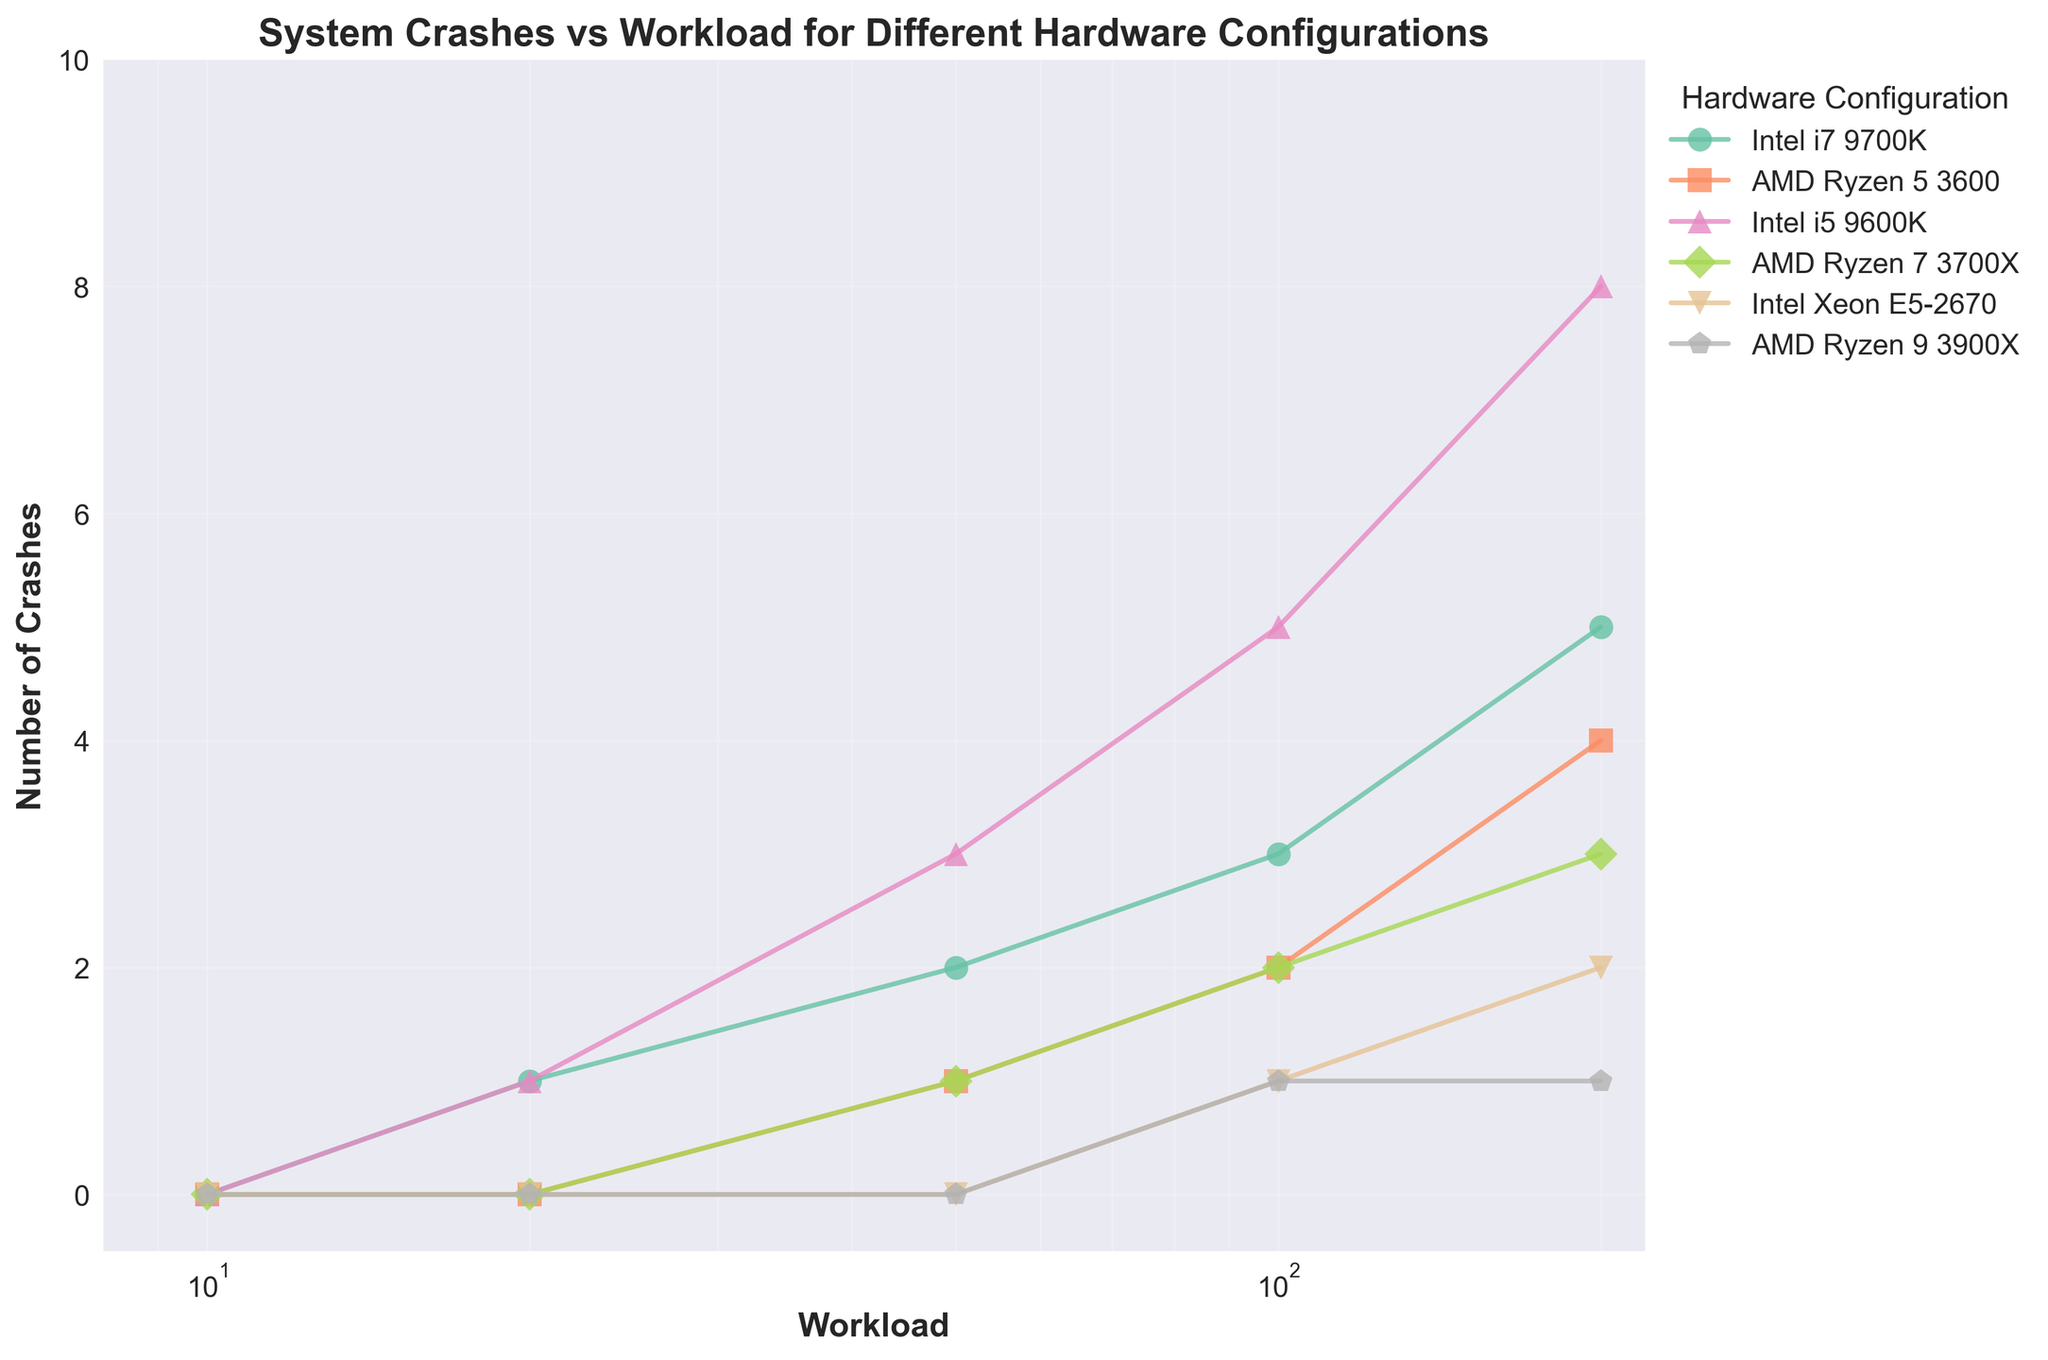What's the title of the plot? The title is located at the top-center of the plot. It serves as a summary of what the graph represents.
Answer: System Crashes vs Workload for Different Hardware Configurations What is the x-axis label? The x-axis label is located at the bottom of the plot. It indicates what the numbers on the x-axis represent.
Answer: Workload What is the y-axis label? The y-axis label is located on the left side of the plot. It indicates what the numbers on the y-axis represent.
Answer: Number of Crashes Which hardware configuration has no crashes up to a workload of 50? By analyzing the data points on the figure for workloads up to 50, you can determine which hardware configuration has no crashes.
Answer: Intel Xeon E5-2670 How many crashes are recorded for the Intel i5 9600K configuration at a workload of 200? Locate the data point for the workload of 200 for the Intel i5 9600K line. The y-value of this point indicates the number of crashes.
Answer: 8 Which configuration starts experiencing crashes at the lowest workload? Compare the workloads at which each configuration first experiences a crash. The configuration with the lowest workload value for a first crash is the answer.
Answer: Intel i7 9700K Between which two configurations is there the greatest difference in crashes at a workload of 100? Examine the y-values for each configuration at a workload of 100 and calculate the differences. The two configurations with the greatest difference in crashes are the answer.
Answer: Intel i5 9600K and AMD Ryzen 9 3900X What is the trend of crashes for AMD Ryzen 7 3700X as the workload increases from 10 to 200? Observe the pattern of data points for the AMD Ryzen 7 3700X configuration as the workload increases. Describe the pattern of increase or decrease in the number of crashes.
Answer: Increasing trend Which configuration shows the least increase in crashes from 50 to 200? Calculate the increase in crashes from workload 50 to 200 for each configuration and compare them. The configuration with the smallest increase is the answer.
Answer: AMD Ryzen 9 3900X 